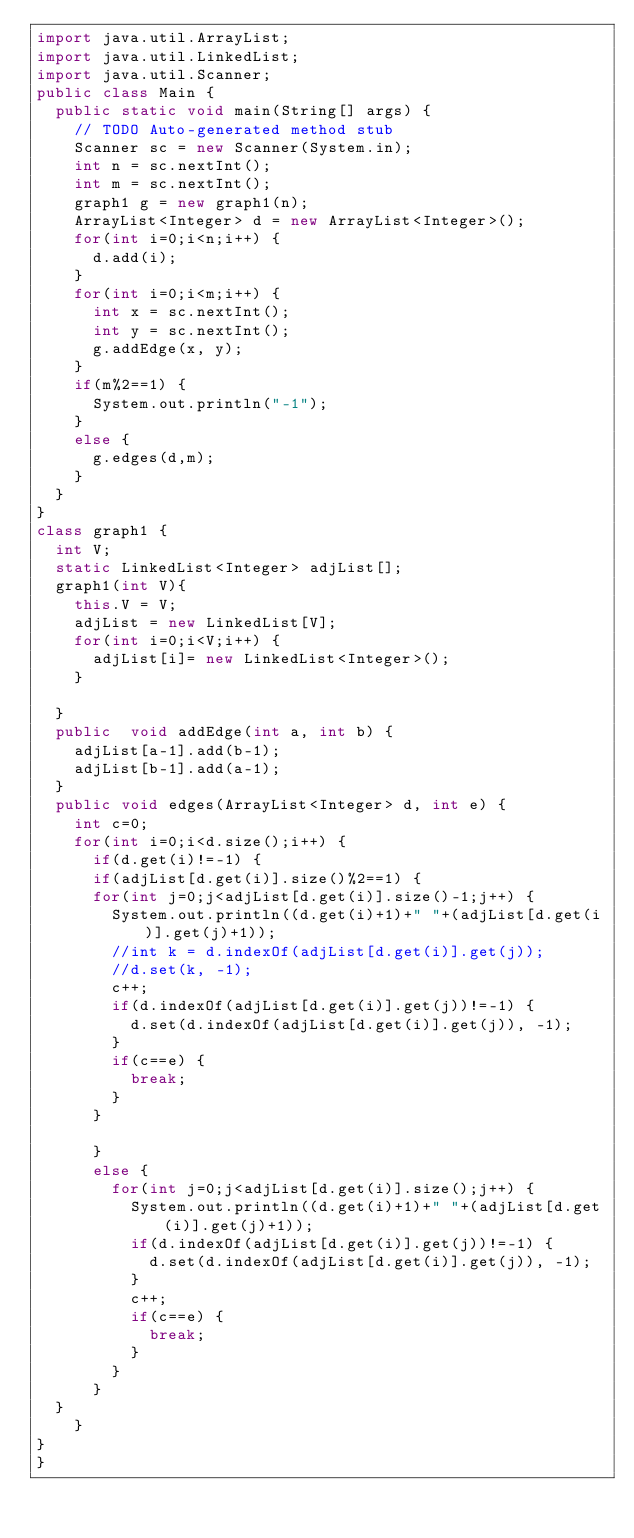<code> <loc_0><loc_0><loc_500><loc_500><_Java_>import java.util.ArrayList;
import java.util.LinkedList;
import java.util.Scanner;
public class Main {
	public static void main(String[] args) {
		// TODO Auto-generated method stub
		Scanner sc = new Scanner(System.in);
		int n = sc.nextInt();
		int m = sc.nextInt();
		graph1 g = new graph1(n);
		ArrayList<Integer> d = new ArrayList<Integer>();
		for(int i=0;i<n;i++) {
			d.add(i);
		}
		for(int i=0;i<m;i++) {
			int x = sc.nextInt();
			int y = sc.nextInt();
			g.addEdge(x, y);
		}
		if(m%2==1) {
			System.out.println("-1");
		}
		else {
			g.edges(d,m);
		}
	}
}
class graph1 {
	int V;
	static LinkedList<Integer> adjList[];
	graph1(int V){
		this.V = V;
		adjList = new LinkedList[V];
		for(int i=0;i<V;i++) {
			adjList[i]= new LinkedList<Integer>();
		}
		
	}
	public  void addEdge(int a, int b) {
		adjList[a-1].add(b-1);
		adjList[b-1].add(a-1);
	}
	public void edges(ArrayList<Integer> d, int e) {
		int c=0;
		for(int i=0;i<d.size();i++) {
			if(d.get(i)!=-1) {
			if(adjList[d.get(i)].size()%2==1) {
			for(int j=0;j<adjList[d.get(i)].size()-1;j++) {
				System.out.println((d.get(i)+1)+" "+(adjList[d.get(i)].get(j)+1));
				//int k = d.indexOf(adjList[d.get(i)].get(j));
				//d.set(k, -1);
				c++;
				if(d.indexOf(adjList[d.get(i)].get(j))!=-1) {
					d.set(d.indexOf(adjList[d.get(i)].get(j)), -1);
				}
				if(c==e) {
					break;
				}
			}
			
			}
			else {
				for(int j=0;j<adjList[d.get(i)].size();j++) {
					System.out.println((d.get(i)+1)+" "+(adjList[d.get(i)].get(j)+1));
					if(d.indexOf(adjList[d.get(i)].get(j))!=-1) {
						d.set(d.indexOf(adjList[d.get(i)].get(j)), -1);
					}
					c++;
					if(c==e) {
						break;
					}
				}
			}
	}
		}
}
}</code> 